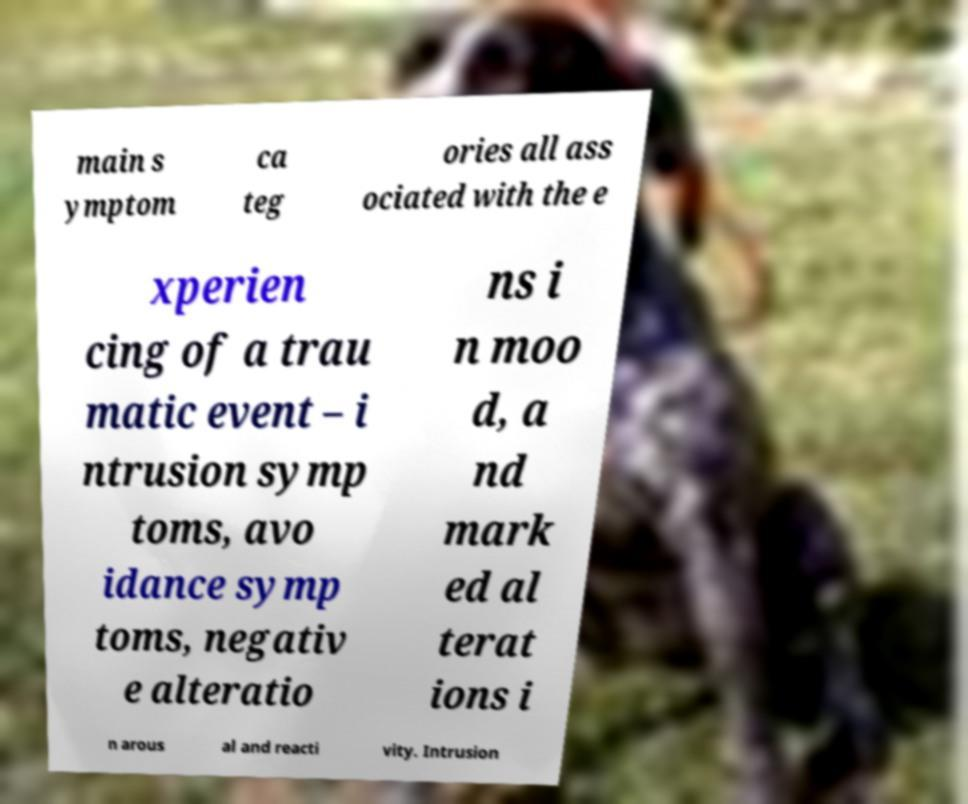Please read and relay the text visible in this image. What does it say? main s ymptom ca teg ories all ass ociated with the e xperien cing of a trau matic event – i ntrusion symp toms, avo idance symp toms, negativ e alteratio ns i n moo d, a nd mark ed al terat ions i n arous al and reacti vity. Intrusion 